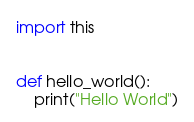<code> <loc_0><loc_0><loc_500><loc_500><_Python_>import this


def hello_world():
    print("Hello World")
</code> 